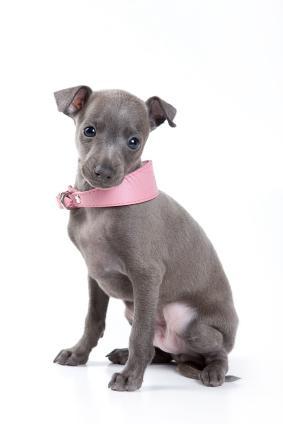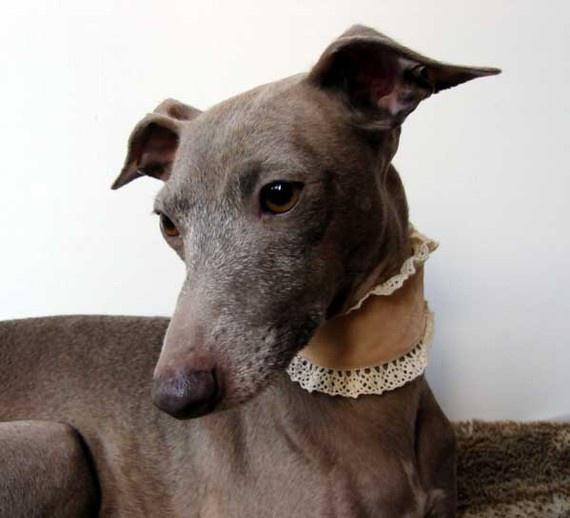The first image is the image on the left, the second image is the image on the right. Examine the images to the left and right. Is the description "One of the dogs has a pink collar." accurate? Answer yes or no. Yes. 